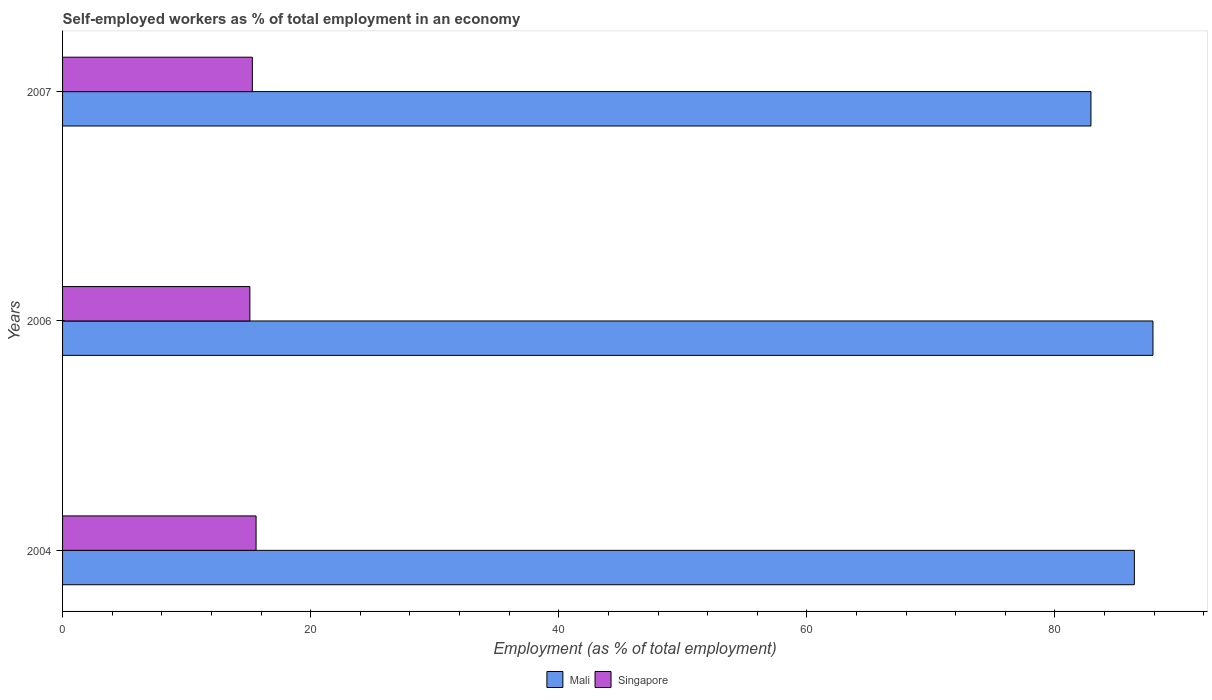How many different coloured bars are there?
Make the answer very short. 2. How many groups of bars are there?
Offer a terse response. 3. Are the number of bars per tick equal to the number of legend labels?
Your response must be concise. Yes. How many bars are there on the 2nd tick from the top?
Give a very brief answer. 2. How many bars are there on the 3rd tick from the bottom?
Offer a terse response. 2. What is the percentage of self-employed workers in Singapore in 2006?
Keep it short and to the point. 15.1. Across all years, what is the maximum percentage of self-employed workers in Singapore?
Give a very brief answer. 15.6. Across all years, what is the minimum percentage of self-employed workers in Mali?
Give a very brief answer. 82.9. What is the total percentage of self-employed workers in Mali in the graph?
Keep it short and to the point. 257.2. What is the difference between the percentage of self-employed workers in Singapore in 2004 and that in 2007?
Your answer should be compact. 0.3. What is the difference between the percentage of self-employed workers in Singapore in 2004 and the percentage of self-employed workers in Mali in 2006?
Your answer should be very brief. -72.3. What is the average percentage of self-employed workers in Mali per year?
Give a very brief answer. 85.73. In the year 2007, what is the difference between the percentage of self-employed workers in Mali and percentage of self-employed workers in Singapore?
Your response must be concise. 67.6. In how many years, is the percentage of self-employed workers in Singapore greater than 4 %?
Provide a short and direct response. 3. What is the ratio of the percentage of self-employed workers in Mali in 2004 to that in 2007?
Provide a succinct answer. 1.04. What is the difference between the highest and the second highest percentage of self-employed workers in Singapore?
Keep it short and to the point. 0.3. What is the difference between the highest and the lowest percentage of self-employed workers in Mali?
Keep it short and to the point. 5. What does the 1st bar from the top in 2006 represents?
Your answer should be very brief. Singapore. What does the 2nd bar from the bottom in 2006 represents?
Keep it short and to the point. Singapore. How many bars are there?
Provide a short and direct response. 6. Are all the bars in the graph horizontal?
Make the answer very short. Yes. How many years are there in the graph?
Give a very brief answer. 3. Are the values on the major ticks of X-axis written in scientific E-notation?
Keep it short and to the point. No. Where does the legend appear in the graph?
Your answer should be compact. Bottom center. How many legend labels are there?
Keep it short and to the point. 2. How are the legend labels stacked?
Your answer should be compact. Horizontal. What is the title of the graph?
Ensure brevity in your answer.  Self-employed workers as % of total employment in an economy. Does "Liechtenstein" appear as one of the legend labels in the graph?
Provide a short and direct response. No. What is the label or title of the X-axis?
Your answer should be compact. Employment (as % of total employment). What is the label or title of the Y-axis?
Make the answer very short. Years. What is the Employment (as % of total employment) of Mali in 2004?
Ensure brevity in your answer.  86.4. What is the Employment (as % of total employment) in Singapore in 2004?
Provide a short and direct response. 15.6. What is the Employment (as % of total employment) in Mali in 2006?
Give a very brief answer. 87.9. What is the Employment (as % of total employment) in Singapore in 2006?
Your answer should be compact. 15.1. What is the Employment (as % of total employment) of Mali in 2007?
Make the answer very short. 82.9. What is the Employment (as % of total employment) of Singapore in 2007?
Offer a very short reply. 15.3. Across all years, what is the maximum Employment (as % of total employment) in Mali?
Keep it short and to the point. 87.9. Across all years, what is the maximum Employment (as % of total employment) in Singapore?
Offer a very short reply. 15.6. Across all years, what is the minimum Employment (as % of total employment) in Mali?
Keep it short and to the point. 82.9. Across all years, what is the minimum Employment (as % of total employment) in Singapore?
Give a very brief answer. 15.1. What is the total Employment (as % of total employment) of Mali in the graph?
Your answer should be compact. 257.2. What is the total Employment (as % of total employment) in Singapore in the graph?
Give a very brief answer. 46. What is the difference between the Employment (as % of total employment) in Mali in 2004 and that in 2006?
Offer a terse response. -1.5. What is the difference between the Employment (as % of total employment) in Singapore in 2004 and that in 2006?
Ensure brevity in your answer.  0.5. What is the difference between the Employment (as % of total employment) of Singapore in 2004 and that in 2007?
Provide a short and direct response. 0.3. What is the difference between the Employment (as % of total employment) in Mali in 2004 and the Employment (as % of total employment) in Singapore in 2006?
Your response must be concise. 71.3. What is the difference between the Employment (as % of total employment) in Mali in 2004 and the Employment (as % of total employment) in Singapore in 2007?
Ensure brevity in your answer.  71.1. What is the difference between the Employment (as % of total employment) in Mali in 2006 and the Employment (as % of total employment) in Singapore in 2007?
Ensure brevity in your answer.  72.6. What is the average Employment (as % of total employment) in Mali per year?
Provide a short and direct response. 85.73. What is the average Employment (as % of total employment) of Singapore per year?
Offer a very short reply. 15.33. In the year 2004, what is the difference between the Employment (as % of total employment) in Mali and Employment (as % of total employment) in Singapore?
Make the answer very short. 70.8. In the year 2006, what is the difference between the Employment (as % of total employment) in Mali and Employment (as % of total employment) in Singapore?
Give a very brief answer. 72.8. In the year 2007, what is the difference between the Employment (as % of total employment) in Mali and Employment (as % of total employment) in Singapore?
Offer a terse response. 67.6. What is the ratio of the Employment (as % of total employment) in Mali in 2004 to that in 2006?
Give a very brief answer. 0.98. What is the ratio of the Employment (as % of total employment) of Singapore in 2004 to that in 2006?
Give a very brief answer. 1.03. What is the ratio of the Employment (as % of total employment) in Mali in 2004 to that in 2007?
Your answer should be compact. 1.04. What is the ratio of the Employment (as % of total employment) in Singapore in 2004 to that in 2007?
Your answer should be compact. 1.02. What is the ratio of the Employment (as % of total employment) of Mali in 2006 to that in 2007?
Your answer should be very brief. 1.06. What is the ratio of the Employment (as % of total employment) of Singapore in 2006 to that in 2007?
Make the answer very short. 0.99. What is the difference between the highest and the second highest Employment (as % of total employment) of Mali?
Ensure brevity in your answer.  1.5. What is the difference between the highest and the second highest Employment (as % of total employment) of Singapore?
Provide a succinct answer. 0.3. What is the difference between the highest and the lowest Employment (as % of total employment) in Singapore?
Your answer should be very brief. 0.5. 